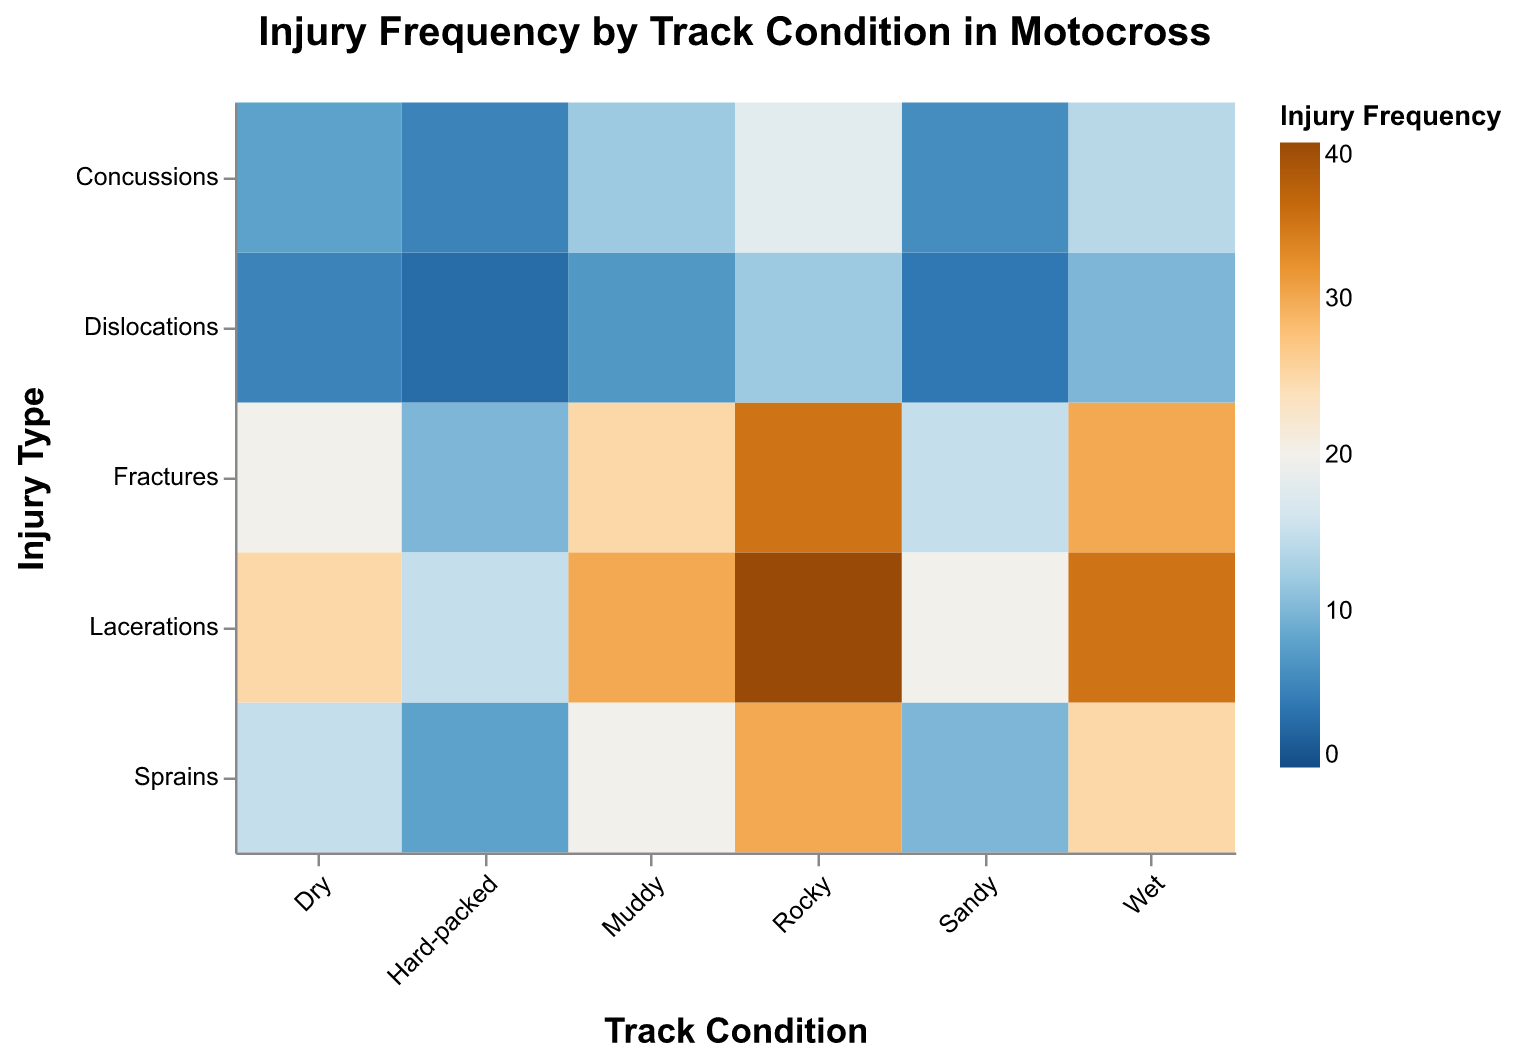What is the title of the heatmap? The title is usually located at the top and it tells us what the heatmap is about. In this case, the title reads "Injury Frequency by Track Condition in Motocross."
Answer: Injury Frequency by Track Condition in Motocross Which track condition has the highest overall injury frequency? By looking at the heatmap, we can see that it uses colors to denote frequency. The darkest color represents the highest values. Rocky track condition shows the darkest colors for many injury types, implying it has the highest overall frequency.
Answer: Rocky Which track condition has the lowest frequency of fractures? We compare the colors under the "Fractures" category for each track condition. The lightest color indicates the lowest frequency. The Hard-packed condition has the lightest color under Fractures.
Answer: Hard-packed How many types of injuries are shown in the heatmap? Each row in the heatmap represents a different type of injury. By counting the rows, we can see there are 5 types of injuries.
Answer: 5 types What is the total frequency of injuries for the Dry track condition? We need to sum up the frequencies of all types of injuries for the Dry track condition: 20 (Fractures) + 5 (Dislocations) + 8 (Concussions) + 15 (Sprains) + 25 (Lacerations).
Answer: 73 Which injury type has the highest frequency on the Wet track condition? By looking at the Wet track condition column, we notice that Lacerations have the highest value compared to other injury types.
Answer: Lacerations What is the difference in concussion frequency between Rocky and Sandy track conditions? For concussions, Rocky has a frequency of 18 and Sandy has 6. The difference is 18 - 6.
Answer: 12 Which track condition shows a closer frequency between dislocations and sprains? By examining the difference between Dislocations and Sprains for each track condition, we see that Sandy has 4 (Dislocations) and 10 (Sprains), so the difference is 6, which is the closest among all conditions.
Answer: Sandy How does the injury frequency for Sprains compare between Dry and Muddy track conditions? Sprains in Dry condition have a frequency of 15, while in Muddy it is 20. Dry has 5 fewer sprains than Muddy.
Answer: Dry has fewer sprains than Muddy by 5 What track condition has the highest variability in injury types? Variability can be estimated by comparing the range of frequencies for each track condition. In the Rocky condition, the range (difference between maximum and minimum injury frequency) is greatest from 12 (Dislocations) to 40 (Lacerations).
Answer: Rocky 